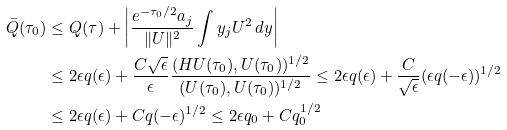<formula> <loc_0><loc_0><loc_500><loc_500>\bar { Q } ( \tau _ { 0 } ) & \leq Q ( \tau ) + \left | \frac { e ^ { - \tau _ { 0 } / 2 } a _ { j } } { \| U \| ^ { 2 } } \int y _ { j } U ^ { 2 } \, d y \right | \\ & \leq 2 \epsilon q ( \epsilon ) + \frac { C \sqrt { \epsilon } } { \epsilon } \frac { ( H U ( \tau _ { 0 } ) , U ( \tau _ { 0 } ) ) ^ { 1 / 2 } } { ( U ( \tau _ { 0 } ) , U ( \tau _ { 0 } ) ) ^ { 1 / 2 } } \leq 2 \epsilon q ( \epsilon ) + \frac { C } { \sqrt { \epsilon } } ( \epsilon q ( - \epsilon ) ) ^ { 1 / 2 } \\ & \leq 2 \epsilon q ( \epsilon ) + C q ( - \epsilon ) ^ { 1 / 2 } \leq 2 \epsilon q _ { 0 } + C q _ { 0 } ^ { 1 / 2 }</formula> 